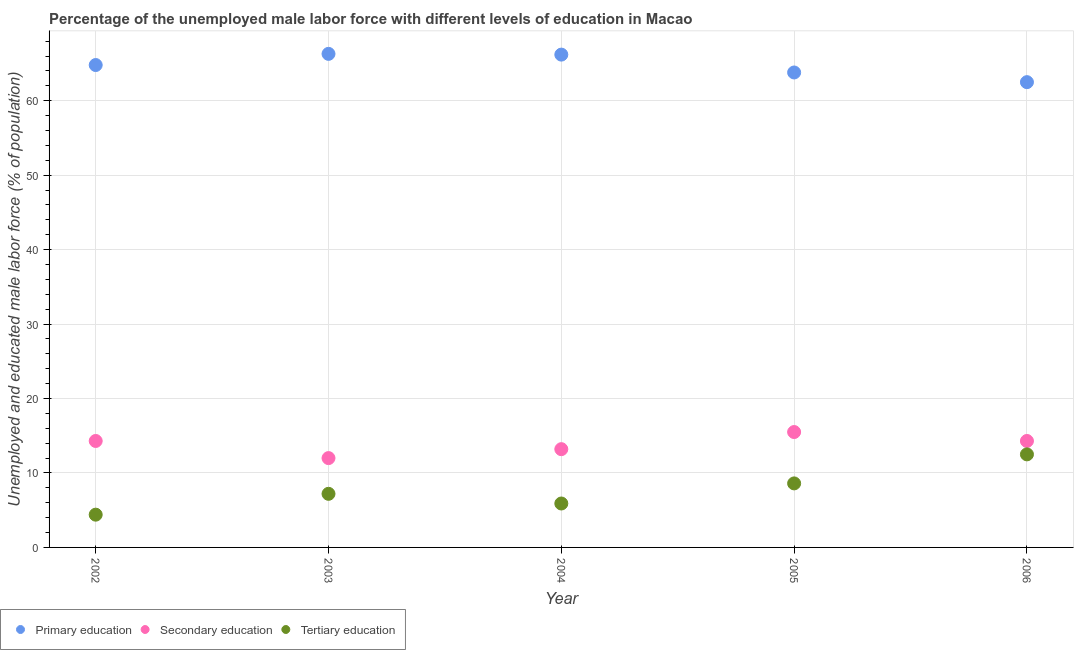What is the percentage of male labor force who received tertiary education in 2004?
Offer a very short reply. 5.9. Across all years, what is the minimum percentage of male labor force who received tertiary education?
Make the answer very short. 4.4. In which year was the percentage of male labor force who received tertiary education minimum?
Your answer should be very brief. 2002. What is the total percentage of male labor force who received secondary education in the graph?
Your response must be concise. 69.3. What is the difference between the percentage of male labor force who received secondary education in 2004 and that in 2006?
Your answer should be compact. -1.1. What is the difference between the percentage of male labor force who received tertiary education in 2003 and the percentage of male labor force who received secondary education in 2002?
Provide a short and direct response. -7.1. What is the average percentage of male labor force who received tertiary education per year?
Offer a terse response. 7.72. In the year 2002, what is the difference between the percentage of male labor force who received primary education and percentage of male labor force who received secondary education?
Provide a short and direct response. 50.5. In how many years, is the percentage of male labor force who received primary education greater than 32 %?
Your response must be concise. 5. What is the ratio of the percentage of male labor force who received tertiary education in 2002 to that in 2005?
Keep it short and to the point. 0.51. Is the percentage of male labor force who received primary education in 2002 less than that in 2005?
Ensure brevity in your answer.  No. Is the difference between the percentage of male labor force who received primary education in 2005 and 2006 greater than the difference between the percentage of male labor force who received tertiary education in 2005 and 2006?
Offer a very short reply. Yes. What is the difference between the highest and the second highest percentage of male labor force who received tertiary education?
Your answer should be compact. 3.9. What is the difference between the highest and the lowest percentage of male labor force who received secondary education?
Provide a succinct answer. 3.5. In how many years, is the percentage of male labor force who received primary education greater than the average percentage of male labor force who received primary education taken over all years?
Ensure brevity in your answer.  3. Does the percentage of male labor force who received tertiary education monotonically increase over the years?
Offer a very short reply. No. Is the percentage of male labor force who received primary education strictly greater than the percentage of male labor force who received tertiary education over the years?
Keep it short and to the point. Yes. What is the difference between two consecutive major ticks on the Y-axis?
Offer a terse response. 10. Are the values on the major ticks of Y-axis written in scientific E-notation?
Give a very brief answer. No. How are the legend labels stacked?
Your answer should be very brief. Horizontal. What is the title of the graph?
Your answer should be very brief. Percentage of the unemployed male labor force with different levels of education in Macao. Does "Neonatal" appear as one of the legend labels in the graph?
Keep it short and to the point. No. What is the label or title of the X-axis?
Provide a short and direct response. Year. What is the label or title of the Y-axis?
Offer a terse response. Unemployed and educated male labor force (% of population). What is the Unemployed and educated male labor force (% of population) in Primary education in 2002?
Your answer should be very brief. 64.8. What is the Unemployed and educated male labor force (% of population) in Secondary education in 2002?
Give a very brief answer. 14.3. What is the Unemployed and educated male labor force (% of population) of Tertiary education in 2002?
Provide a short and direct response. 4.4. What is the Unemployed and educated male labor force (% of population) of Primary education in 2003?
Offer a terse response. 66.3. What is the Unemployed and educated male labor force (% of population) in Tertiary education in 2003?
Provide a short and direct response. 7.2. What is the Unemployed and educated male labor force (% of population) of Primary education in 2004?
Provide a short and direct response. 66.2. What is the Unemployed and educated male labor force (% of population) in Secondary education in 2004?
Make the answer very short. 13.2. What is the Unemployed and educated male labor force (% of population) of Tertiary education in 2004?
Offer a very short reply. 5.9. What is the Unemployed and educated male labor force (% of population) of Primary education in 2005?
Provide a short and direct response. 63.8. What is the Unemployed and educated male labor force (% of population) in Secondary education in 2005?
Your answer should be very brief. 15.5. What is the Unemployed and educated male labor force (% of population) in Tertiary education in 2005?
Provide a short and direct response. 8.6. What is the Unemployed and educated male labor force (% of population) in Primary education in 2006?
Provide a short and direct response. 62.5. What is the Unemployed and educated male labor force (% of population) in Secondary education in 2006?
Ensure brevity in your answer.  14.3. What is the Unemployed and educated male labor force (% of population) in Tertiary education in 2006?
Ensure brevity in your answer.  12.5. Across all years, what is the maximum Unemployed and educated male labor force (% of population) of Primary education?
Make the answer very short. 66.3. Across all years, what is the minimum Unemployed and educated male labor force (% of population) of Primary education?
Ensure brevity in your answer.  62.5. Across all years, what is the minimum Unemployed and educated male labor force (% of population) in Tertiary education?
Your response must be concise. 4.4. What is the total Unemployed and educated male labor force (% of population) of Primary education in the graph?
Give a very brief answer. 323.6. What is the total Unemployed and educated male labor force (% of population) of Secondary education in the graph?
Your answer should be compact. 69.3. What is the total Unemployed and educated male labor force (% of population) of Tertiary education in the graph?
Give a very brief answer. 38.6. What is the difference between the Unemployed and educated male labor force (% of population) of Secondary education in 2002 and that in 2003?
Your answer should be very brief. 2.3. What is the difference between the Unemployed and educated male labor force (% of population) of Secondary education in 2002 and that in 2004?
Your answer should be very brief. 1.1. What is the difference between the Unemployed and educated male labor force (% of population) of Primary education in 2002 and that in 2005?
Make the answer very short. 1. What is the difference between the Unemployed and educated male labor force (% of population) of Tertiary education in 2002 and that in 2005?
Make the answer very short. -4.2. What is the difference between the Unemployed and educated male labor force (% of population) in Primary education in 2002 and that in 2006?
Make the answer very short. 2.3. What is the difference between the Unemployed and educated male labor force (% of population) of Secondary education in 2002 and that in 2006?
Make the answer very short. 0. What is the difference between the Unemployed and educated male labor force (% of population) in Tertiary education in 2003 and that in 2004?
Your response must be concise. 1.3. What is the difference between the Unemployed and educated male labor force (% of population) of Primary education in 2003 and that in 2005?
Your answer should be compact. 2.5. What is the difference between the Unemployed and educated male labor force (% of population) in Tertiary education in 2003 and that in 2005?
Offer a terse response. -1.4. What is the difference between the Unemployed and educated male labor force (% of population) in Primary education in 2003 and that in 2006?
Your answer should be compact. 3.8. What is the difference between the Unemployed and educated male labor force (% of population) of Tertiary education in 2003 and that in 2006?
Offer a very short reply. -5.3. What is the difference between the Unemployed and educated male labor force (% of population) of Secondary education in 2004 and that in 2005?
Offer a terse response. -2.3. What is the difference between the Unemployed and educated male labor force (% of population) of Primary education in 2004 and that in 2006?
Make the answer very short. 3.7. What is the difference between the Unemployed and educated male labor force (% of population) in Tertiary education in 2004 and that in 2006?
Keep it short and to the point. -6.6. What is the difference between the Unemployed and educated male labor force (% of population) of Secondary education in 2005 and that in 2006?
Your answer should be very brief. 1.2. What is the difference between the Unemployed and educated male labor force (% of population) of Primary education in 2002 and the Unemployed and educated male labor force (% of population) of Secondary education in 2003?
Offer a very short reply. 52.8. What is the difference between the Unemployed and educated male labor force (% of population) of Primary education in 2002 and the Unemployed and educated male labor force (% of population) of Tertiary education in 2003?
Offer a terse response. 57.6. What is the difference between the Unemployed and educated male labor force (% of population) in Primary education in 2002 and the Unemployed and educated male labor force (% of population) in Secondary education in 2004?
Offer a very short reply. 51.6. What is the difference between the Unemployed and educated male labor force (% of population) of Primary education in 2002 and the Unemployed and educated male labor force (% of population) of Tertiary education in 2004?
Provide a succinct answer. 58.9. What is the difference between the Unemployed and educated male labor force (% of population) of Primary education in 2002 and the Unemployed and educated male labor force (% of population) of Secondary education in 2005?
Provide a short and direct response. 49.3. What is the difference between the Unemployed and educated male labor force (% of population) of Primary education in 2002 and the Unemployed and educated male labor force (% of population) of Tertiary education in 2005?
Offer a terse response. 56.2. What is the difference between the Unemployed and educated male labor force (% of population) in Secondary education in 2002 and the Unemployed and educated male labor force (% of population) in Tertiary education in 2005?
Provide a succinct answer. 5.7. What is the difference between the Unemployed and educated male labor force (% of population) in Primary education in 2002 and the Unemployed and educated male labor force (% of population) in Secondary education in 2006?
Your response must be concise. 50.5. What is the difference between the Unemployed and educated male labor force (% of population) of Primary education in 2002 and the Unemployed and educated male labor force (% of population) of Tertiary education in 2006?
Your response must be concise. 52.3. What is the difference between the Unemployed and educated male labor force (% of population) of Primary education in 2003 and the Unemployed and educated male labor force (% of population) of Secondary education in 2004?
Ensure brevity in your answer.  53.1. What is the difference between the Unemployed and educated male labor force (% of population) of Primary education in 2003 and the Unemployed and educated male labor force (% of population) of Tertiary education in 2004?
Keep it short and to the point. 60.4. What is the difference between the Unemployed and educated male labor force (% of population) of Secondary education in 2003 and the Unemployed and educated male labor force (% of population) of Tertiary education in 2004?
Provide a succinct answer. 6.1. What is the difference between the Unemployed and educated male labor force (% of population) in Primary education in 2003 and the Unemployed and educated male labor force (% of population) in Secondary education in 2005?
Provide a short and direct response. 50.8. What is the difference between the Unemployed and educated male labor force (% of population) of Primary education in 2003 and the Unemployed and educated male labor force (% of population) of Tertiary education in 2005?
Your answer should be compact. 57.7. What is the difference between the Unemployed and educated male labor force (% of population) in Secondary education in 2003 and the Unemployed and educated male labor force (% of population) in Tertiary education in 2005?
Your response must be concise. 3.4. What is the difference between the Unemployed and educated male labor force (% of population) of Primary education in 2003 and the Unemployed and educated male labor force (% of population) of Secondary education in 2006?
Offer a very short reply. 52. What is the difference between the Unemployed and educated male labor force (% of population) of Primary education in 2003 and the Unemployed and educated male labor force (% of population) of Tertiary education in 2006?
Your response must be concise. 53.8. What is the difference between the Unemployed and educated male labor force (% of population) of Primary education in 2004 and the Unemployed and educated male labor force (% of population) of Secondary education in 2005?
Your response must be concise. 50.7. What is the difference between the Unemployed and educated male labor force (% of population) of Primary education in 2004 and the Unemployed and educated male labor force (% of population) of Tertiary education in 2005?
Make the answer very short. 57.6. What is the difference between the Unemployed and educated male labor force (% of population) of Secondary education in 2004 and the Unemployed and educated male labor force (% of population) of Tertiary education in 2005?
Provide a succinct answer. 4.6. What is the difference between the Unemployed and educated male labor force (% of population) in Primary education in 2004 and the Unemployed and educated male labor force (% of population) in Secondary education in 2006?
Provide a short and direct response. 51.9. What is the difference between the Unemployed and educated male labor force (% of population) in Primary education in 2004 and the Unemployed and educated male labor force (% of population) in Tertiary education in 2006?
Offer a terse response. 53.7. What is the difference between the Unemployed and educated male labor force (% of population) in Secondary education in 2004 and the Unemployed and educated male labor force (% of population) in Tertiary education in 2006?
Your answer should be very brief. 0.7. What is the difference between the Unemployed and educated male labor force (% of population) of Primary education in 2005 and the Unemployed and educated male labor force (% of population) of Secondary education in 2006?
Your answer should be very brief. 49.5. What is the difference between the Unemployed and educated male labor force (% of population) in Primary education in 2005 and the Unemployed and educated male labor force (% of population) in Tertiary education in 2006?
Make the answer very short. 51.3. What is the average Unemployed and educated male labor force (% of population) in Primary education per year?
Your answer should be compact. 64.72. What is the average Unemployed and educated male labor force (% of population) in Secondary education per year?
Offer a terse response. 13.86. What is the average Unemployed and educated male labor force (% of population) in Tertiary education per year?
Your answer should be very brief. 7.72. In the year 2002, what is the difference between the Unemployed and educated male labor force (% of population) in Primary education and Unemployed and educated male labor force (% of population) in Secondary education?
Offer a terse response. 50.5. In the year 2002, what is the difference between the Unemployed and educated male labor force (% of population) of Primary education and Unemployed and educated male labor force (% of population) of Tertiary education?
Ensure brevity in your answer.  60.4. In the year 2002, what is the difference between the Unemployed and educated male labor force (% of population) in Secondary education and Unemployed and educated male labor force (% of population) in Tertiary education?
Provide a short and direct response. 9.9. In the year 2003, what is the difference between the Unemployed and educated male labor force (% of population) of Primary education and Unemployed and educated male labor force (% of population) of Secondary education?
Offer a terse response. 54.3. In the year 2003, what is the difference between the Unemployed and educated male labor force (% of population) of Primary education and Unemployed and educated male labor force (% of population) of Tertiary education?
Your answer should be compact. 59.1. In the year 2003, what is the difference between the Unemployed and educated male labor force (% of population) of Secondary education and Unemployed and educated male labor force (% of population) of Tertiary education?
Make the answer very short. 4.8. In the year 2004, what is the difference between the Unemployed and educated male labor force (% of population) in Primary education and Unemployed and educated male labor force (% of population) in Tertiary education?
Keep it short and to the point. 60.3. In the year 2004, what is the difference between the Unemployed and educated male labor force (% of population) in Secondary education and Unemployed and educated male labor force (% of population) in Tertiary education?
Offer a very short reply. 7.3. In the year 2005, what is the difference between the Unemployed and educated male labor force (% of population) in Primary education and Unemployed and educated male labor force (% of population) in Secondary education?
Your response must be concise. 48.3. In the year 2005, what is the difference between the Unemployed and educated male labor force (% of population) in Primary education and Unemployed and educated male labor force (% of population) in Tertiary education?
Your answer should be very brief. 55.2. In the year 2006, what is the difference between the Unemployed and educated male labor force (% of population) of Primary education and Unemployed and educated male labor force (% of population) of Secondary education?
Keep it short and to the point. 48.2. In the year 2006, what is the difference between the Unemployed and educated male labor force (% of population) in Primary education and Unemployed and educated male labor force (% of population) in Tertiary education?
Give a very brief answer. 50. In the year 2006, what is the difference between the Unemployed and educated male labor force (% of population) in Secondary education and Unemployed and educated male labor force (% of population) in Tertiary education?
Offer a very short reply. 1.8. What is the ratio of the Unemployed and educated male labor force (% of population) in Primary education in 2002 to that in 2003?
Keep it short and to the point. 0.98. What is the ratio of the Unemployed and educated male labor force (% of population) of Secondary education in 2002 to that in 2003?
Give a very brief answer. 1.19. What is the ratio of the Unemployed and educated male labor force (% of population) of Tertiary education in 2002 to that in 2003?
Your answer should be compact. 0.61. What is the ratio of the Unemployed and educated male labor force (% of population) in Primary education in 2002 to that in 2004?
Give a very brief answer. 0.98. What is the ratio of the Unemployed and educated male labor force (% of population) of Tertiary education in 2002 to that in 2004?
Provide a succinct answer. 0.75. What is the ratio of the Unemployed and educated male labor force (% of population) of Primary education in 2002 to that in 2005?
Keep it short and to the point. 1.02. What is the ratio of the Unemployed and educated male labor force (% of population) of Secondary education in 2002 to that in 2005?
Give a very brief answer. 0.92. What is the ratio of the Unemployed and educated male labor force (% of population) in Tertiary education in 2002 to that in 2005?
Make the answer very short. 0.51. What is the ratio of the Unemployed and educated male labor force (% of population) in Primary education in 2002 to that in 2006?
Your answer should be very brief. 1.04. What is the ratio of the Unemployed and educated male labor force (% of population) in Secondary education in 2002 to that in 2006?
Your response must be concise. 1. What is the ratio of the Unemployed and educated male labor force (% of population) of Tertiary education in 2002 to that in 2006?
Ensure brevity in your answer.  0.35. What is the ratio of the Unemployed and educated male labor force (% of population) of Primary education in 2003 to that in 2004?
Provide a succinct answer. 1. What is the ratio of the Unemployed and educated male labor force (% of population) in Tertiary education in 2003 to that in 2004?
Your answer should be compact. 1.22. What is the ratio of the Unemployed and educated male labor force (% of population) in Primary education in 2003 to that in 2005?
Provide a succinct answer. 1.04. What is the ratio of the Unemployed and educated male labor force (% of population) in Secondary education in 2003 to that in 2005?
Give a very brief answer. 0.77. What is the ratio of the Unemployed and educated male labor force (% of population) of Tertiary education in 2003 to that in 2005?
Provide a succinct answer. 0.84. What is the ratio of the Unemployed and educated male labor force (% of population) in Primary education in 2003 to that in 2006?
Provide a succinct answer. 1.06. What is the ratio of the Unemployed and educated male labor force (% of population) in Secondary education in 2003 to that in 2006?
Make the answer very short. 0.84. What is the ratio of the Unemployed and educated male labor force (% of population) in Tertiary education in 2003 to that in 2006?
Provide a succinct answer. 0.58. What is the ratio of the Unemployed and educated male labor force (% of population) of Primary education in 2004 to that in 2005?
Ensure brevity in your answer.  1.04. What is the ratio of the Unemployed and educated male labor force (% of population) in Secondary education in 2004 to that in 2005?
Your answer should be very brief. 0.85. What is the ratio of the Unemployed and educated male labor force (% of population) in Tertiary education in 2004 to that in 2005?
Your answer should be very brief. 0.69. What is the ratio of the Unemployed and educated male labor force (% of population) of Primary education in 2004 to that in 2006?
Provide a short and direct response. 1.06. What is the ratio of the Unemployed and educated male labor force (% of population) of Tertiary education in 2004 to that in 2006?
Provide a short and direct response. 0.47. What is the ratio of the Unemployed and educated male labor force (% of population) of Primary education in 2005 to that in 2006?
Ensure brevity in your answer.  1.02. What is the ratio of the Unemployed and educated male labor force (% of population) of Secondary education in 2005 to that in 2006?
Keep it short and to the point. 1.08. What is the ratio of the Unemployed and educated male labor force (% of population) of Tertiary education in 2005 to that in 2006?
Offer a terse response. 0.69. What is the difference between the highest and the second highest Unemployed and educated male labor force (% of population) of Secondary education?
Your answer should be compact. 1.2. What is the difference between the highest and the lowest Unemployed and educated male labor force (% of population) of Secondary education?
Provide a short and direct response. 3.5. 